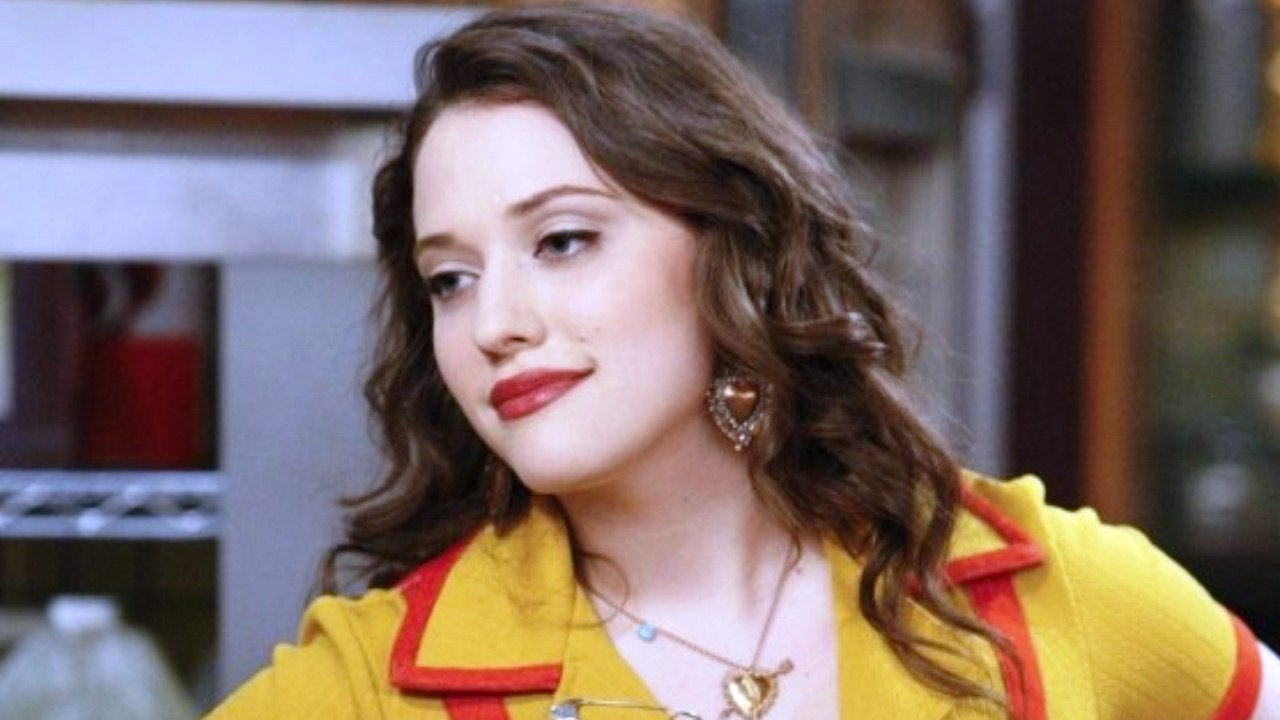What might the choice of jewelry indicate about the setting or the era of the show? The choice of a gold locket necklace and intricately designed earrings suggests a touch of vintage flair, possibly pointing to a character who appreciates classic and timeless pieces. This might hint at a setting that values these aesthetics, such as a story taking place in modern times but with nods to past styles. The jewelry could also underscore a thematic element in the show, possibly centering around tradition, memory, or personal history. 